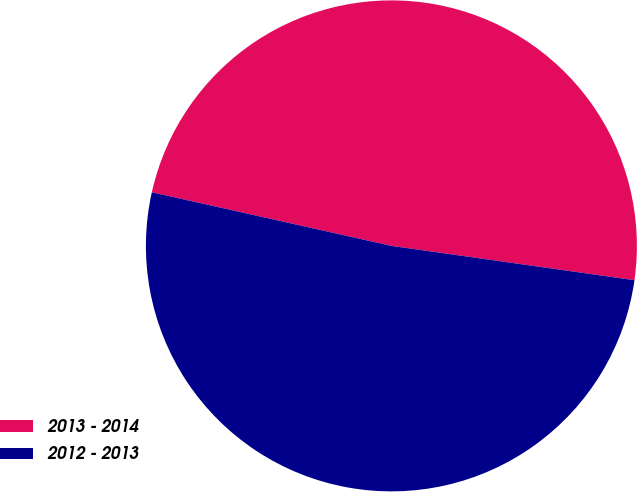Convert chart to OTSL. <chart><loc_0><loc_0><loc_500><loc_500><pie_chart><fcel>2013 - 2014<fcel>2012 - 2013<nl><fcel>48.73%<fcel>51.27%<nl></chart> 